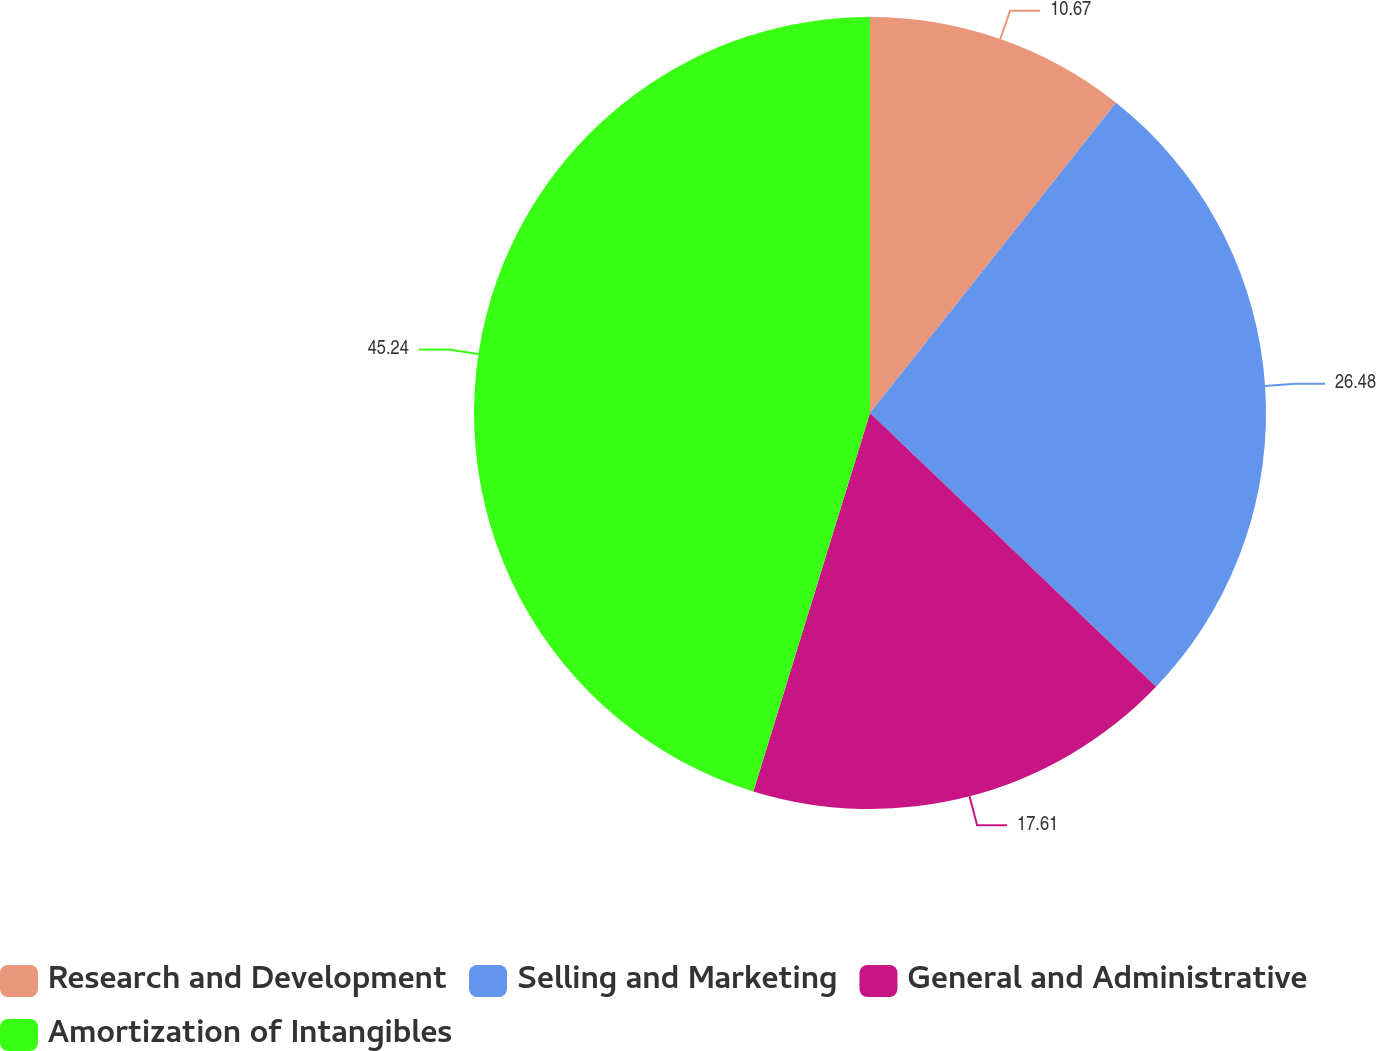<chart> <loc_0><loc_0><loc_500><loc_500><pie_chart><fcel>Research and Development<fcel>Selling and Marketing<fcel>General and Administrative<fcel>Amortization of Intangibles<nl><fcel>10.67%<fcel>26.48%<fcel>17.61%<fcel>45.24%<nl></chart> 